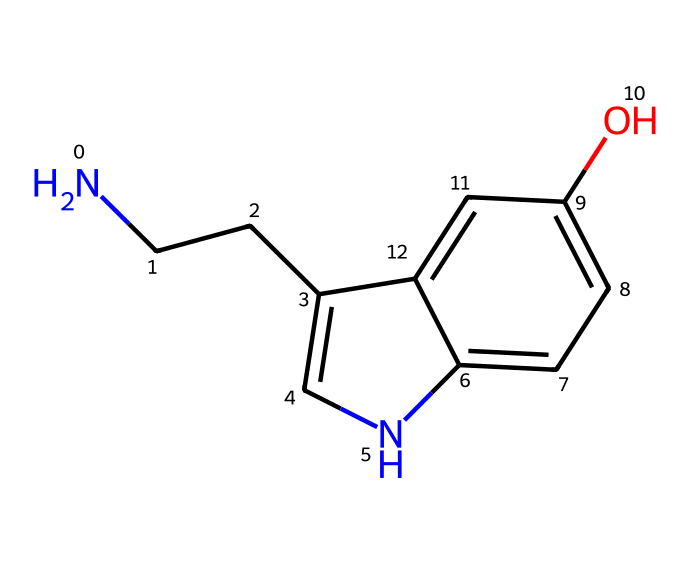How many carbon atoms are present in this compound? By examining the SMILES notation, we can count the carbon atoms: "NCC" indicates 2 carbon atoms, and the ring structure 'c' in "c1c[nH]c2ccc(O)cc12" denotes additional carbon atoms within the aromatic structures. In total, there are 10 carbon atoms.
Answer: 10 What functional group is indicated by the "O" in the structure? The 'O' in the SMILES represents an -OH group, which is characteristic of an alcohol functional group. This suggests the presence of a hydroxyl group in the compound.
Answer: alcohol Does this neurotransmitter contain any nitrogen atoms? The SMILES structure shows 'N' at the beginning, indicating the presence of a nitrogen atom. Counting through the structure, we find one nitrogen atom that is part of the backbone.
Answer: yes What type of ring structure is present in this compound? Upon analyzing the SMILES, it can be observed that there are two interconnected aromatic rings formed by adjacent 'c' and '[nH]' symbols in the notation. These interconnected aromatic rings indicate a fused bicyclic structure, specifically a substituted indole.
Answer: bicyclic What effect does the presence of the hydroxyl group have on the compound's properties? The hydroxyl group (-OH) typically increases the solubility of organic compounds in water due to hydrogen bonding. Additionally, the presence of this group influences the compound’s reactivity and biological interactions, enabling serotonin to act effectively as a neurotransmitter in the body.
Answer: increases solubility How many hydrogen atoms are associated with this compound? To determine the number of hydrogen atoms, we must consider the degree of saturation and the atoms bonded with carbon, nitrogen, and oxygen as represented in the SMILES. Carbon typically forms four bonds, and accounting for the hydrogens needed to maintain tetravalency, we arrive at a total of 12 hydrogen atoms in this structure.
Answer: 12 